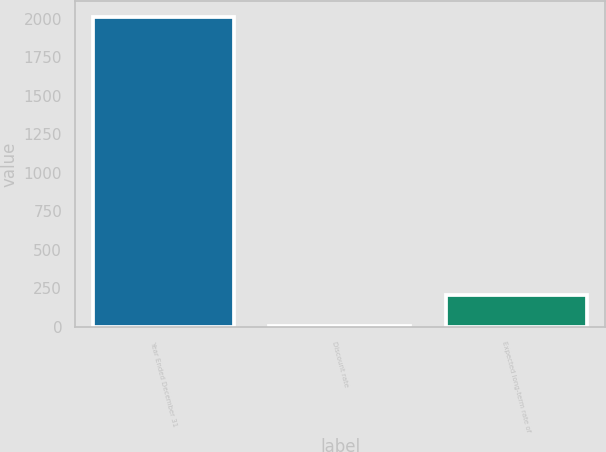<chart> <loc_0><loc_0><loc_500><loc_500><bar_chart><fcel>Year Ended December 31<fcel>Discount rate<fcel>Expected long-term rate of<nl><fcel>2012<fcel>4.75<fcel>205.48<nl></chart> 